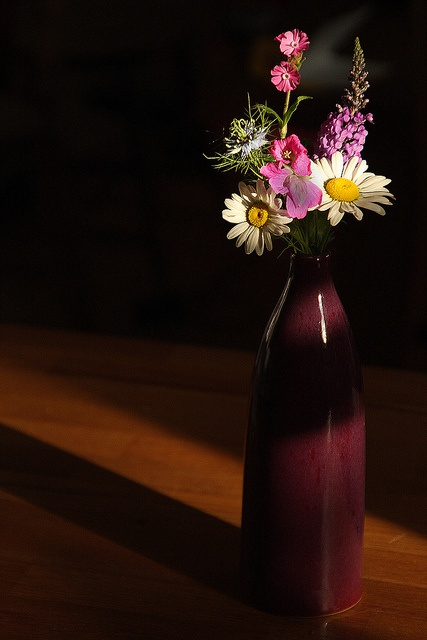Describe the objects in this image and their specific colors. I can see dining table in black and maroon tones and vase in black, maroon, and gray tones in this image. 